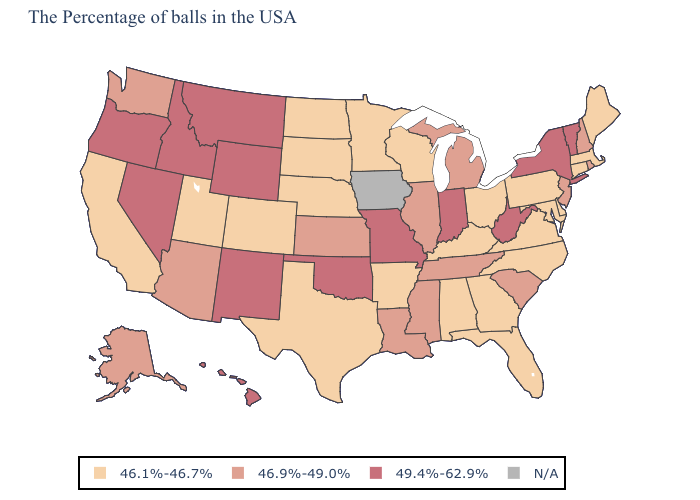Which states have the lowest value in the USA?
Short answer required. Maine, Massachusetts, Connecticut, Delaware, Maryland, Pennsylvania, Virginia, North Carolina, Ohio, Florida, Georgia, Kentucky, Alabama, Wisconsin, Arkansas, Minnesota, Nebraska, Texas, South Dakota, North Dakota, Colorado, Utah, California. What is the highest value in states that border North Carolina?
Answer briefly. 46.9%-49.0%. Does Virginia have the lowest value in the USA?
Answer briefly. Yes. Name the states that have a value in the range N/A?
Give a very brief answer. Iowa. Is the legend a continuous bar?
Answer briefly. No. What is the highest value in states that border Colorado?
Short answer required. 49.4%-62.9%. What is the value of Arkansas?
Write a very short answer. 46.1%-46.7%. What is the value of Kentucky?
Write a very short answer. 46.1%-46.7%. Name the states that have a value in the range N/A?
Concise answer only. Iowa. What is the value of Wyoming?
Write a very short answer. 49.4%-62.9%. What is the value of New Hampshire?
Answer briefly. 46.9%-49.0%. What is the value of Ohio?
Quick response, please. 46.1%-46.7%. Does Oregon have the lowest value in the West?
Short answer required. No. What is the highest value in the South ?
Keep it brief. 49.4%-62.9%. 